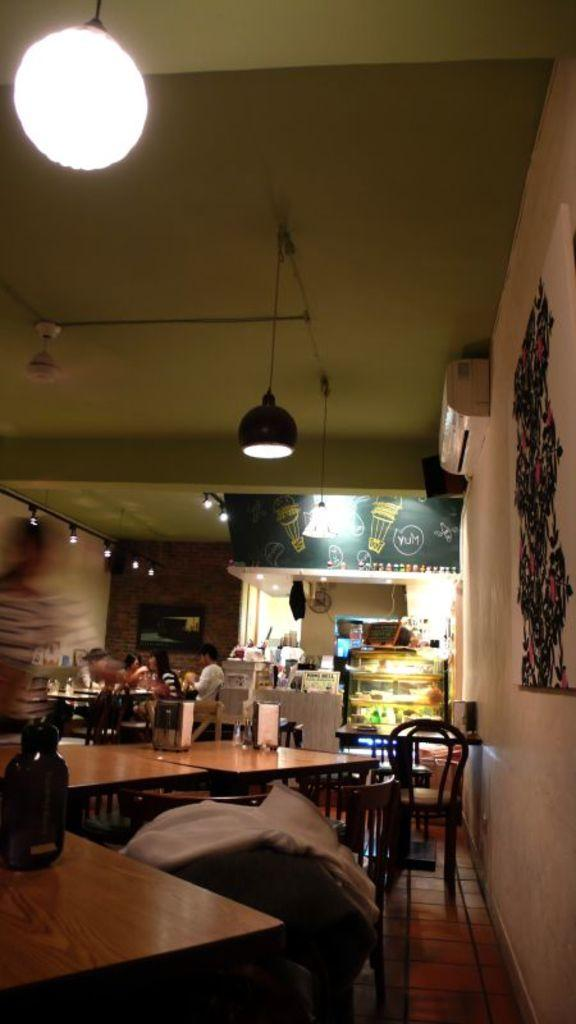What type of establishment is depicted in the image? The image shows an inner view of a restaurant. What can be observed about the people in the restaurant? There are people seated in the restaurant. What type of furniture is present in the restaurant? There are chairs and tables in the restaurant. What type of road can be seen outside the restaurant in the image? There is no road visible in the image, as it shows an inner view of the restaurant. What type of plate is being used by the people in the image? The image does not show any plates being used by the people; it only shows chairs and tables. 